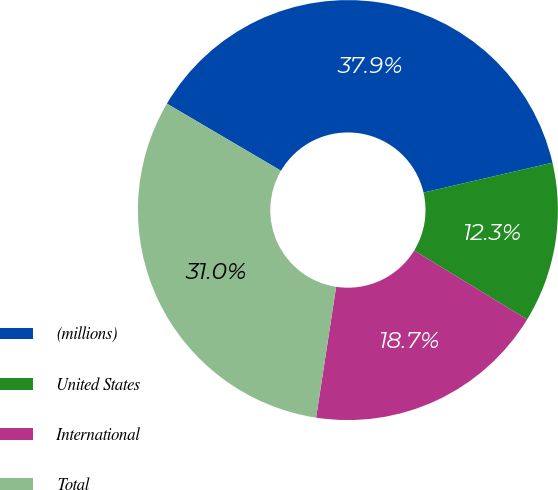Convert chart to OTSL. <chart><loc_0><loc_0><loc_500><loc_500><pie_chart><fcel>(millions)<fcel>United States<fcel>International<fcel>Total<nl><fcel>37.92%<fcel>12.34%<fcel>18.7%<fcel>31.04%<nl></chart> 